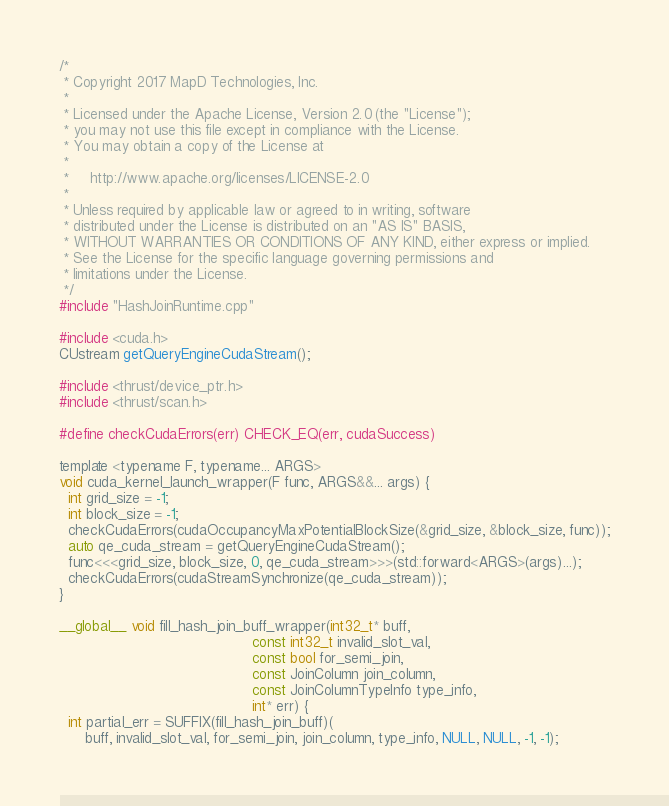Convert code to text. <code><loc_0><loc_0><loc_500><loc_500><_Cuda_>/*
 * Copyright 2017 MapD Technologies, Inc.
 *
 * Licensed under the Apache License, Version 2.0 (the "License");
 * you may not use this file except in compliance with the License.
 * You may obtain a copy of the License at
 *
 *     http://www.apache.org/licenses/LICENSE-2.0
 *
 * Unless required by applicable law or agreed to in writing, software
 * distributed under the License is distributed on an "AS IS" BASIS,
 * WITHOUT WARRANTIES OR CONDITIONS OF ANY KIND, either express or implied.
 * See the License for the specific language governing permissions and
 * limitations under the License.
 */
#include "HashJoinRuntime.cpp"

#include <cuda.h>
CUstream getQueryEngineCudaStream();

#include <thrust/device_ptr.h>
#include <thrust/scan.h>

#define checkCudaErrors(err) CHECK_EQ(err, cudaSuccess)

template <typename F, typename... ARGS>
void cuda_kernel_launch_wrapper(F func, ARGS&&... args) {
  int grid_size = -1;
  int block_size = -1;
  checkCudaErrors(cudaOccupancyMaxPotentialBlockSize(&grid_size, &block_size, func));
  auto qe_cuda_stream = getQueryEngineCudaStream();
  func<<<grid_size, block_size, 0, qe_cuda_stream>>>(std::forward<ARGS>(args)...);
  checkCudaErrors(cudaStreamSynchronize(qe_cuda_stream));
}

__global__ void fill_hash_join_buff_wrapper(int32_t* buff,
                                            const int32_t invalid_slot_val,
                                            const bool for_semi_join,
                                            const JoinColumn join_column,
                                            const JoinColumnTypeInfo type_info,
                                            int* err) {
  int partial_err = SUFFIX(fill_hash_join_buff)(
      buff, invalid_slot_val, for_semi_join, join_column, type_info, NULL, NULL, -1, -1);</code> 